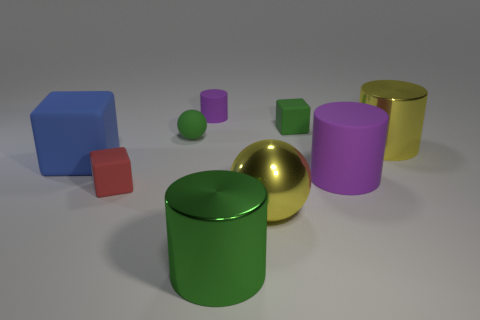Add 1 large metal objects. How many objects exist? 10 Subtract all cubes. How many objects are left? 6 Subtract 0 brown blocks. How many objects are left? 9 Subtract all big green metal cylinders. Subtract all red rubber things. How many objects are left? 7 Add 5 purple cylinders. How many purple cylinders are left? 7 Add 7 green blocks. How many green blocks exist? 8 